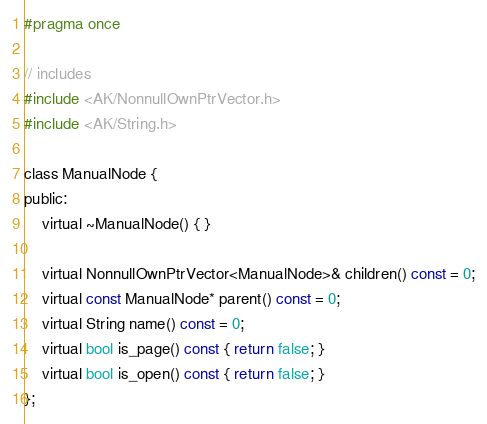<code> <loc_0><loc_0><loc_500><loc_500><_C_>
#pragma once

// includes
#include <AK/NonnullOwnPtrVector.h>
#include <AK/String.h>

class ManualNode {
public:
    virtual ~ManualNode() { }

    virtual NonnullOwnPtrVector<ManualNode>& children() const = 0;
    virtual const ManualNode* parent() const = 0;
    virtual String name() const = 0;
    virtual bool is_page() const { return false; }
    virtual bool is_open() const { return false; }
};</code> 